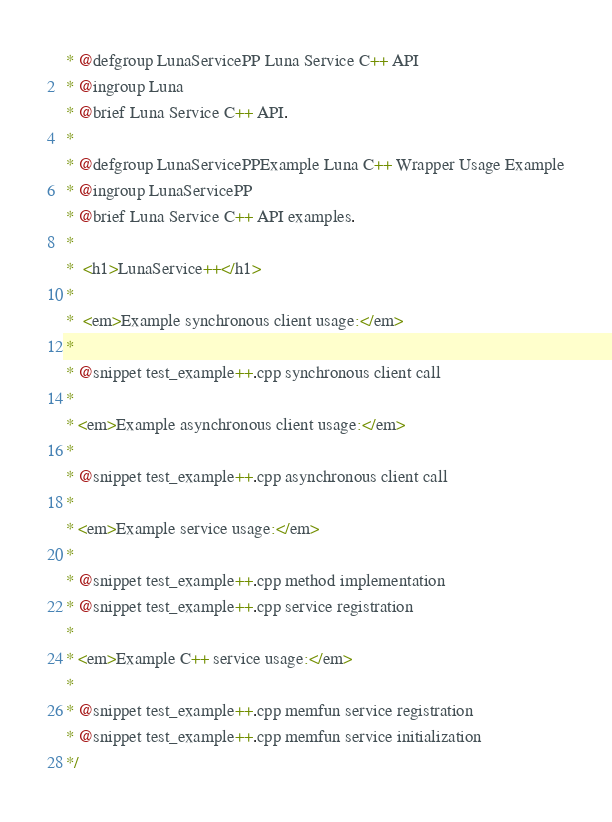Convert code to text. <code><loc_0><loc_0><loc_500><loc_500><_C++_> * @defgroup LunaServicePP Luna Service C++ API
 * @ingroup Luna
 * @brief Luna Service C++ API.
 *
 * @defgroup LunaServicePPExample Luna C++ Wrapper Usage Example
 * @ingroup LunaServicePP
 * @brief Luna Service C++ API examples.
 *
 *  <h1>LunaService++</h1>
 *
 *  <em>Example synchronous client usage:</em>
 *
 * @snippet test_example++.cpp synchronous client call
 *
 * <em>Example asynchronous client usage:</em>
 *
 * @snippet test_example++.cpp asynchronous client call
 *
 * <em>Example service usage:</em>
 *
 * @snippet test_example++.cpp method implementation
 * @snippet test_example++.cpp service registration
 *
 * <em>Example C++ service usage:</em>
 *
 * @snippet test_example++.cpp memfun service registration
 * @snippet test_example++.cpp memfun service initialization
 */
</code> 